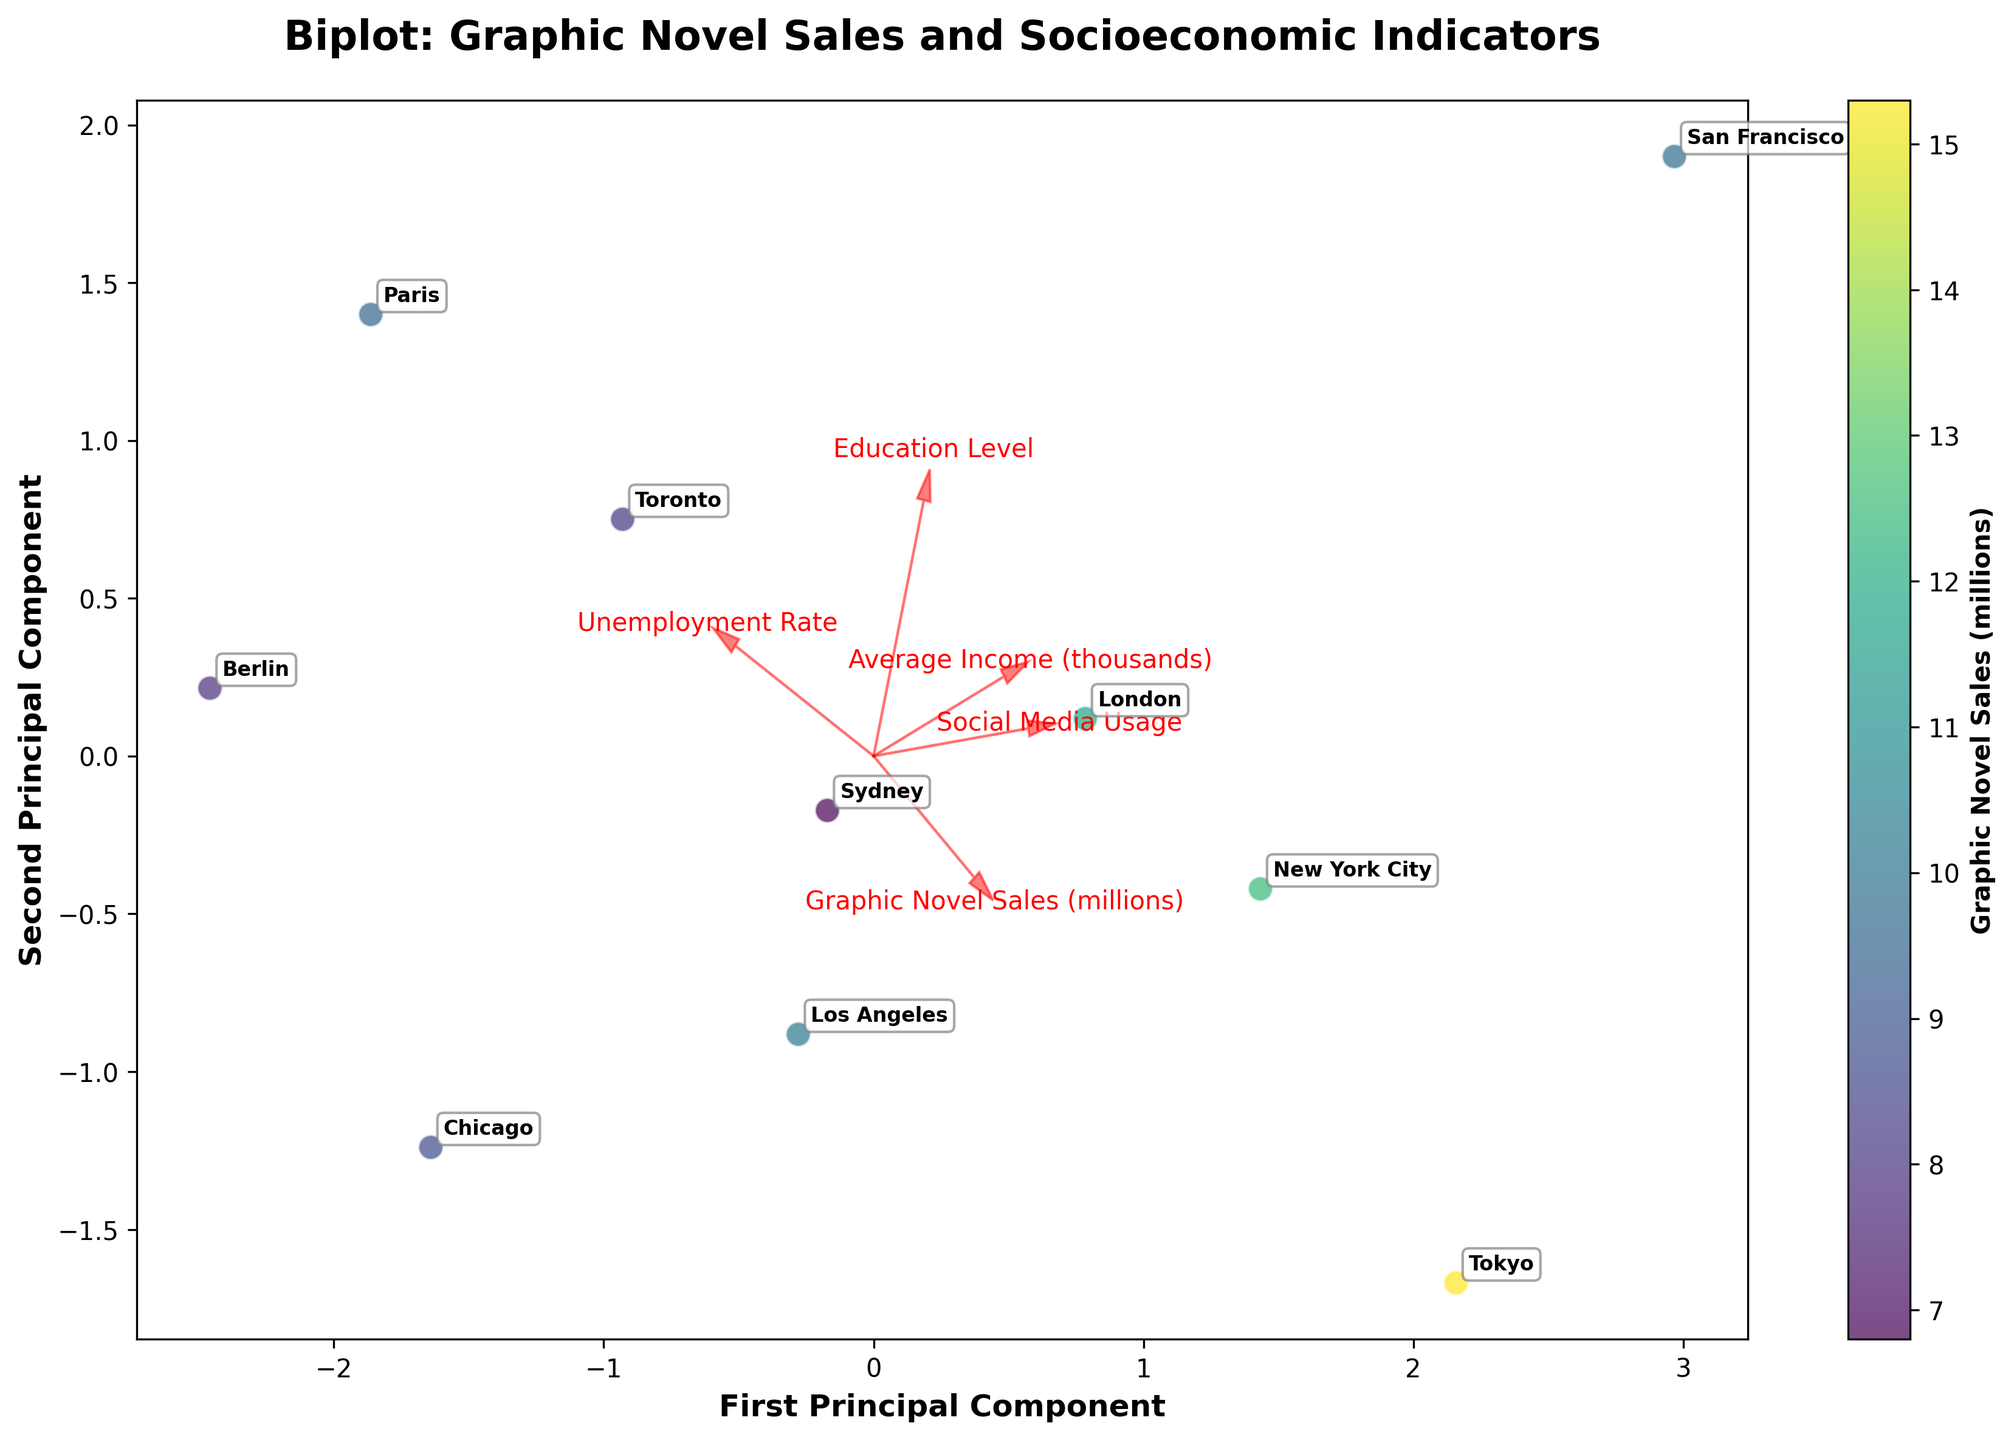What's the title of the figure? The title of the figure is usually displayed at the top of the plot, in this case, it clearly says "Biplot: Graphic Novel Sales and Socioeconomic Indicators".
Answer: Biplot: Graphic Novel Sales and Socioeconomic Indicators Which region has the highest graphic novel sales according to the color of the data points? The color intensity representing graphic novel sales is strongest for the data point labeled "Tokyo".
Answer: Tokyo What's the label of the x-axis? The x-axis label gives information about the variable plotted along this axis. It shows "First Principal Component".
Answer: First Principal Component What does the length and direction of feature vectors indicate in the biplot? The length and direction of the feature vectors reflect how strongly each socioeconomic indicator correlates with the principal components. Longer arrows suggest stronger correlations; the direction shows how each indicator relates to the principal components.
Answer: Strength and direction of socioeconomic indicators' correlation with principal components How many principal components are shown in the biplot? The biplot in question displays two principal components, aligning with the x and y axes.
Answer: Two Which regions have both lower average income and higher unemployment rates based on their positions in the plot? Observing the positions in the plot, regions like Paris and Berlin are located where both average income is lower, and unemployment rates are higher.
Answer: Paris and Berlin Which socioeconomic indicator seems to have the least impact on graphic novel sales? The length of the feature vector "Education Level" is shorter compared to others, suggesting it has the least impact on graphic novel sales.
Answer: Education Level Which region is closest to the end of the "Social Media Usage" arrow and what might it imply? The region closest to the end of the "Social Media Usage" arrow is San Francisco, implying high social media usage is strongly associated with graphic novel sales in this region.
Answer: San Francisco Which feature vectors are nearly opposite in direction? By examining the directions of the feature vectors, "Unemployment Rate" and "Average Income" are nearly opposite, indicating a negative correlation between them.
Answer: Unemployment Rate and Average Income How does the biplot represent the relationship between graphic novel sales and unemployment rate? The vector for "Unemployment Rate" points in a different direction compared to "Graphic Novel Sales", indicating a likely negative relationship between these two variables.
Answer: Negative relationship 